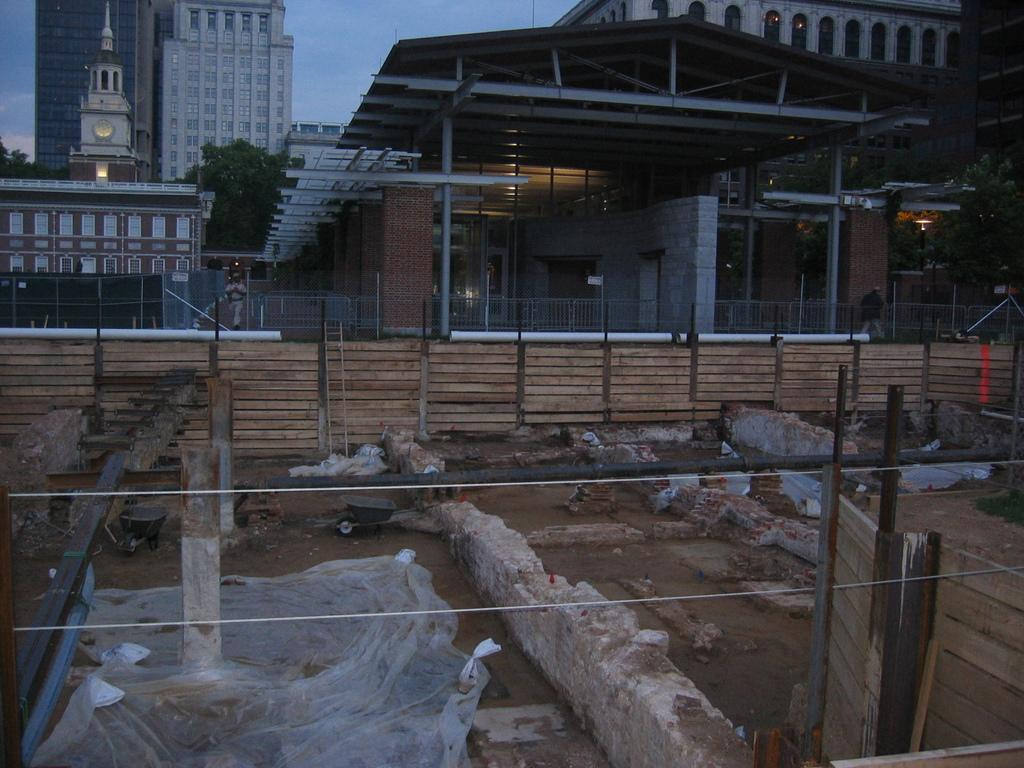What can be seen in the background of the image? There are buildings, trees, and a fencing in the background of the image. Can you describe the type of vegetation present in the background? The vegetation in the background consists of trees. What architectural feature is visible in the background? There is a fencing in the background of the image. What type of net can be seen catching the sparks in the image? There is no net or sparks present in the image. What emotion is being expressed by the regretful figure in the image? There is no figure expressing regret in the image. 